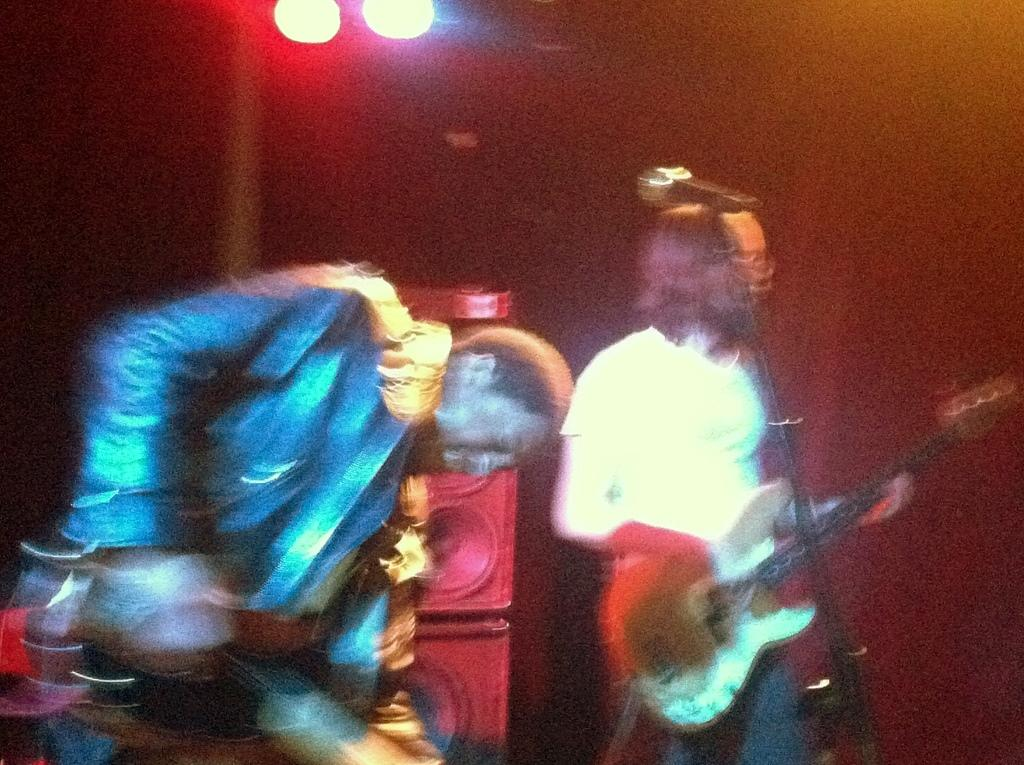What are the two persons in the image doing? The two persons in the image are playing guitars. Can you describe any additional features in the image? Yes, there are lights visible in the image, as well as speakers and a microphone. What is the background of the image like? There is a wall in the background of the image. What type of pollution can be seen coming from the railway in the image? There is no railway present in the image, so it is not possible to determine if there is any pollution. 